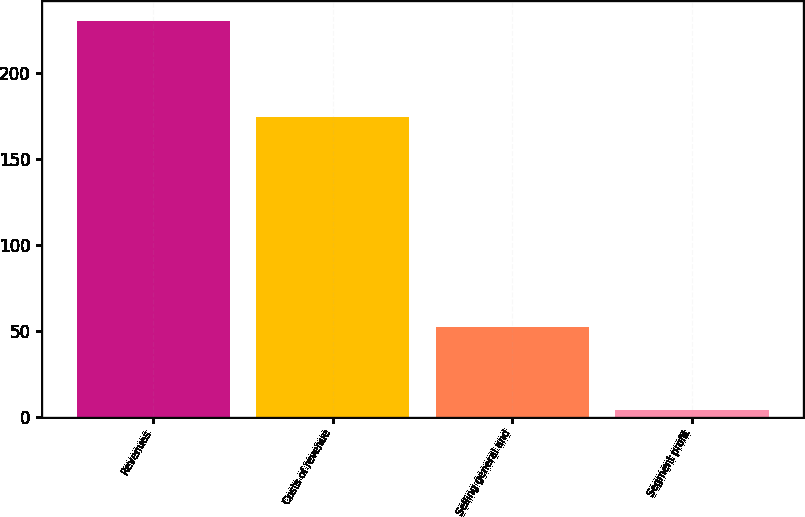Convert chart. <chart><loc_0><loc_0><loc_500><loc_500><bar_chart><fcel>Revenues<fcel>Costs of revenue<fcel>Selling general and<fcel>Segment profit<nl><fcel>230<fcel>174<fcel>52<fcel>4<nl></chart> 